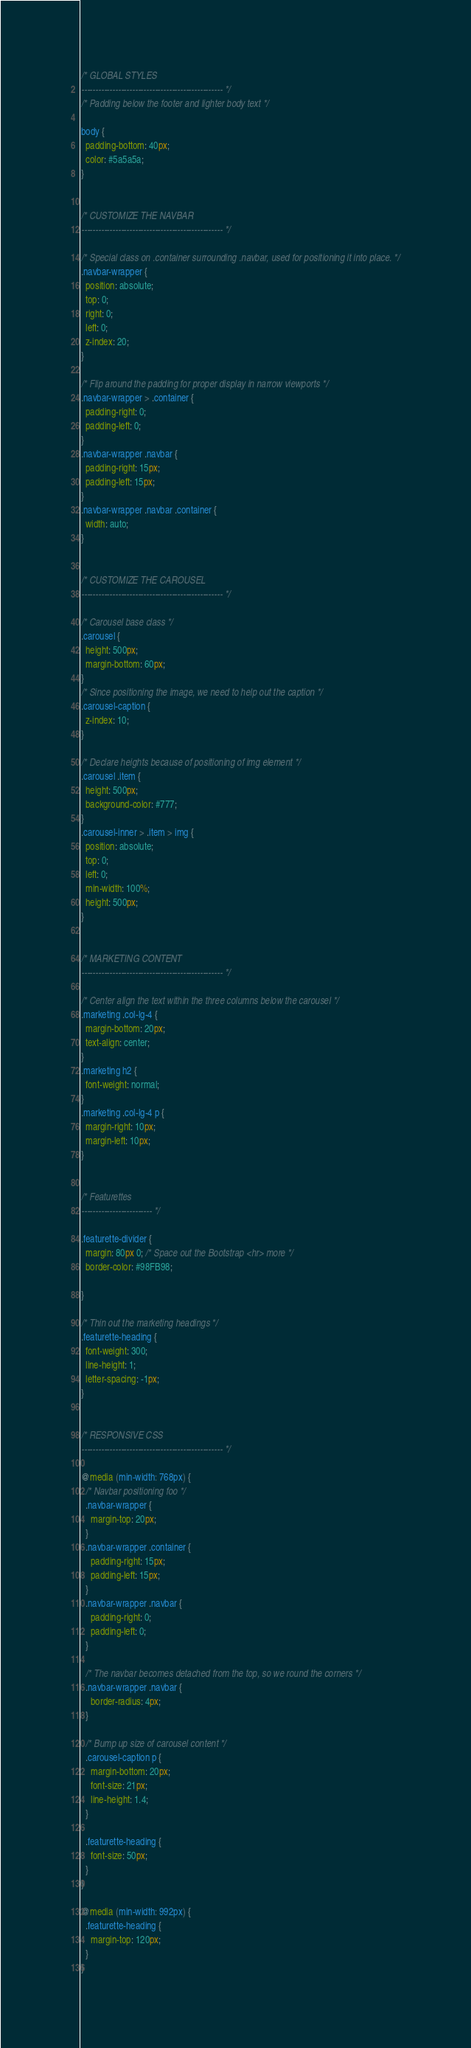Convert code to text. <code><loc_0><loc_0><loc_500><loc_500><_CSS_>/* GLOBAL STYLES
-------------------------------------------------- */
/* Padding below the footer and lighter body text */

body {
  padding-bottom: 40px;
  color: #5a5a5a;
}


/* CUSTOMIZE THE NAVBAR
-------------------------------------------------- */

/* Special class on .container surrounding .navbar, used for positioning it into place. */
.navbar-wrapper {
  position: absolute;
  top: 0;
  right: 0;
  left: 0;
  z-index: 20;
}

/* Flip around the padding for proper display in narrow viewports */
.navbar-wrapper > .container {
  padding-right: 0;
  padding-left: 0;
}
.navbar-wrapper .navbar {
  padding-right: 15px;
  padding-left: 15px;
}
.navbar-wrapper .navbar .container {
  width: auto;
}


/* CUSTOMIZE THE CAROUSEL
-------------------------------------------------- */

/* Carousel base class */
.carousel {
  height: 500px;
  margin-bottom: 60px;
}
/* Since positioning the image, we need to help out the caption */
.carousel-caption {
  z-index: 10;
}

/* Declare heights because of positioning of img element */
.carousel .item {
  height: 500px;
  background-color: #777;
}
.carousel-inner > .item > img {
  position: absolute;
  top: 0;
  left: 0;
  min-width: 100%;
  height: 500px;
}


/* MARKETING CONTENT
-------------------------------------------------- */

/* Center align the text within the three columns below the carousel */
.marketing .col-lg-4 {
  margin-bottom: 20px;
  text-align: center;
}
.marketing h2 {
  font-weight: normal;
}
.marketing .col-lg-4 p {
  margin-right: 10px;
  margin-left: 10px;
}


/* Featurettes
------------------------- */

.featurette-divider {
  margin: 80px 0; /* Space out the Bootstrap <hr> more */
  border-color: #98FB98;

}

/* Thin out the marketing headings */
.featurette-heading {
  font-weight: 300;
  line-height: 1;
  letter-spacing: -1px;
}


/* RESPONSIVE CSS
-------------------------------------------------- */

@media (min-width: 768px) {
  /* Navbar positioning foo */
  .navbar-wrapper {
    margin-top: 20px;
  }
  .navbar-wrapper .container {
    padding-right: 15px;
    padding-left: 15px;
  }
  .navbar-wrapper .navbar {
    padding-right: 0;
    padding-left: 0;
  }

  /* The navbar becomes detached from the top, so we round the corners */
  .navbar-wrapper .navbar {
    border-radius: 4px;
  }

  /* Bump up size of carousel content */
  .carousel-caption p {
    margin-bottom: 20px;
    font-size: 21px;
    line-height: 1.4;
  }

  .featurette-heading {
    font-size: 50px;
  }
}

@media (min-width: 992px) {
  .featurette-heading {
    margin-top: 120px;
  }
}
</code> 